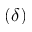<formula> <loc_0><loc_0><loc_500><loc_500>\left ( \delta \right )</formula> 